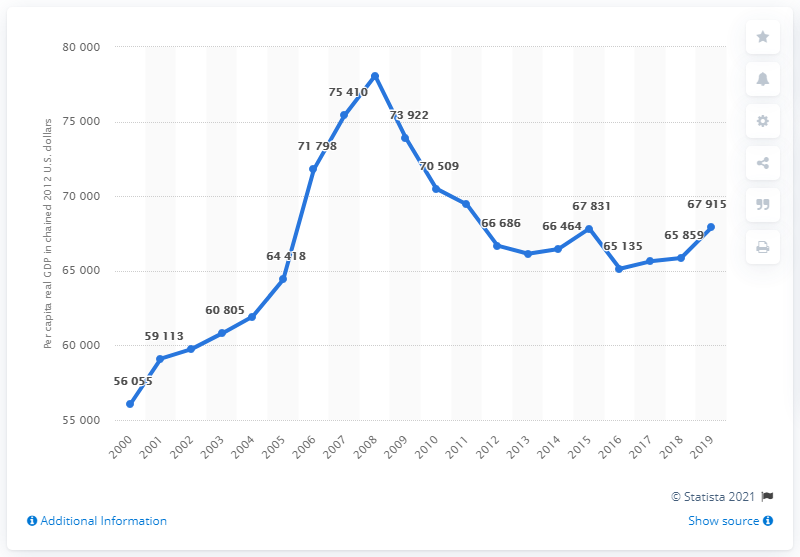Draw attention to some important aspects in this diagram. In 2008, the per capita real GDP of Wyoming was the highest it had been in that year. 